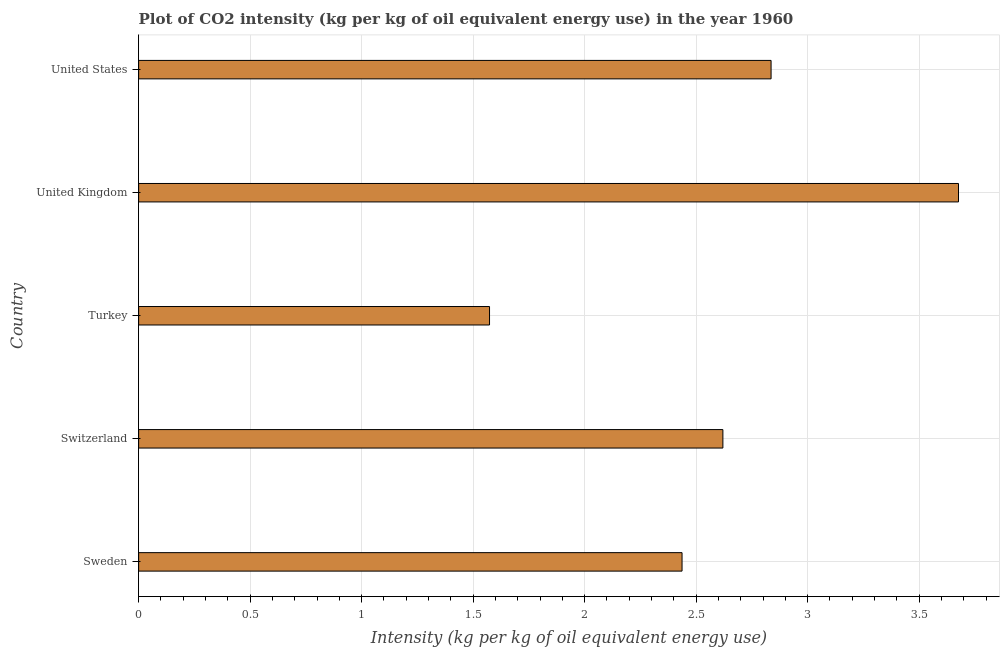Does the graph contain any zero values?
Make the answer very short. No. Does the graph contain grids?
Provide a short and direct response. Yes. What is the title of the graph?
Your answer should be very brief. Plot of CO2 intensity (kg per kg of oil equivalent energy use) in the year 1960. What is the label or title of the X-axis?
Offer a very short reply. Intensity (kg per kg of oil equivalent energy use). What is the label or title of the Y-axis?
Make the answer very short. Country. What is the co2 intensity in Sweden?
Provide a short and direct response. 2.44. Across all countries, what is the maximum co2 intensity?
Keep it short and to the point. 3.68. Across all countries, what is the minimum co2 intensity?
Provide a succinct answer. 1.57. In which country was the co2 intensity maximum?
Make the answer very short. United Kingdom. In which country was the co2 intensity minimum?
Your response must be concise. Turkey. What is the sum of the co2 intensity?
Provide a succinct answer. 13.14. What is the difference between the co2 intensity in United Kingdom and United States?
Ensure brevity in your answer.  0.84. What is the average co2 intensity per country?
Offer a very short reply. 2.63. What is the median co2 intensity?
Offer a very short reply. 2.62. In how many countries, is the co2 intensity greater than 1.1 kg?
Offer a very short reply. 5. What is the ratio of the co2 intensity in Switzerland to that in United Kingdom?
Your answer should be compact. 0.71. What is the difference between the highest and the second highest co2 intensity?
Make the answer very short. 0.84. Is the sum of the co2 intensity in Sweden and Switzerland greater than the maximum co2 intensity across all countries?
Offer a terse response. Yes. How many countries are there in the graph?
Your response must be concise. 5. What is the difference between two consecutive major ticks on the X-axis?
Ensure brevity in your answer.  0.5. Are the values on the major ticks of X-axis written in scientific E-notation?
Offer a terse response. No. What is the Intensity (kg per kg of oil equivalent energy use) in Sweden?
Your answer should be compact. 2.44. What is the Intensity (kg per kg of oil equivalent energy use) in Switzerland?
Give a very brief answer. 2.62. What is the Intensity (kg per kg of oil equivalent energy use) in Turkey?
Give a very brief answer. 1.57. What is the Intensity (kg per kg of oil equivalent energy use) in United Kingdom?
Give a very brief answer. 3.68. What is the Intensity (kg per kg of oil equivalent energy use) of United States?
Your answer should be compact. 2.84. What is the difference between the Intensity (kg per kg of oil equivalent energy use) in Sweden and Switzerland?
Your answer should be compact. -0.18. What is the difference between the Intensity (kg per kg of oil equivalent energy use) in Sweden and Turkey?
Your response must be concise. 0.86. What is the difference between the Intensity (kg per kg of oil equivalent energy use) in Sweden and United Kingdom?
Make the answer very short. -1.24. What is the difference between the Intensity (kg per kg of oil equivalent energy use) in Sweden and United States?
Ensure brevity in your answer.  -0.4. What is the difference between the Intensity (kg per kg of oil equivalent energy use) in Switzerland and Turkey?
Provide a short and direct response. 1.05. What is the difference between the Intensity (kg per kg of oil equivalent energy use) in Switzerland and United Kingdom?
Provide a succinct answer. -1.06. What is the difference between the Intensity (kg per kg of oil equivalent energy use) in Switzerland and United States?
Your answer should be compact. -0.22. What is the difference between the Intensity (kg per kg of oil equivalent energy use) in Turkey and United Kingdom?
Provide a succinct answer. -2.1. What is the difference between the Intensity (kg per kg of oil equivalent energy use) in Turkey and United States?
Provide a short and direct response. -1.26. What is the difference between the Intensity (kg per kg of oil equivalent energy use) in United Kingdom and United States?
Your response must be concise. 0.84. What is the ratio of the Intensity (kg per kg of oil equivalent energy use) in Sweden to that in Turkey?
Make the answer very short. 1.55. What is the ratio of the Intensity (kg per kg of oil equivalent energy use) in Sweden to that in United Kingdom?
Offer a very short reply. 0.66. What is the ratio of the Intensity (kg per kg of oil equivalent energy use) in Sweden to that in United States?
Keep it short and to the point. 0.86. What is the ratio of the Intensity (kg per kg of oil equivalent energy use) in Switzerland to that in Turkey?
Offer a terse response. 1.67. What is the ratio of the Intensity (kg per kg of oil equivalent energy use) in Switzerland to that in United Kingdom?
Ensure brevity in your answer.  0.71. What is the ratio of the Intensity (kg per kg of oil equivalent energy use) in Switzerland to that in United States?
Ensure brevity in your answer.  0.92. What is the ratio of the Intensity (kg per kg of oil equivalent energy use) in Turkey to that in United Kingdom?
Ensure brevity in your answer.  0.43. What is the ratio of the Intensity (kg per kg of oil equivalent energy use) in Turkey to that in United States?
Offer a terse response. 0.56. What is the ratio of the Intensity (kg per kg of oil equivalent energy use) in United Kingdom to that in United States?
Your response must be concise. 1.3. 